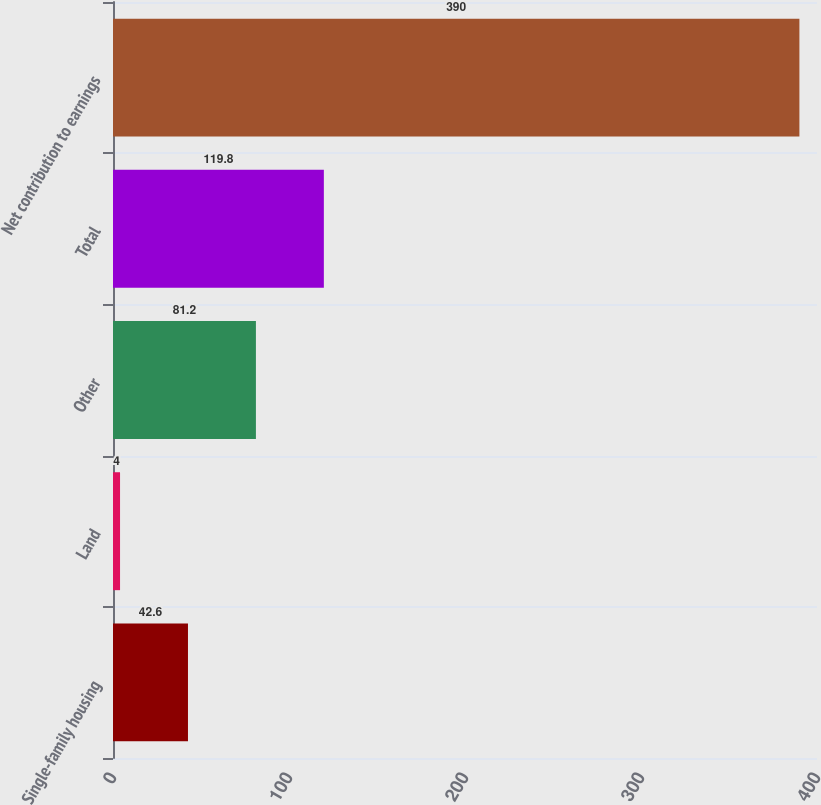Convert chart. <chart><loc_0><loc_0><loc_500><loc_500><bar_chart><fcel>Single-family housing<fcel>Land<fcel>Other<fcel>Total<fcel>Net contribution to earnings<nl><fcel>42.6<fcel>4<fcel>81.2<fcel>119.8<fcel>390<nl></chart> 